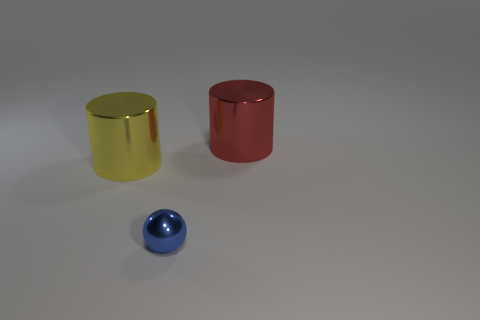Can you describe the surface the objects are on? The surface on which the objects are placed is smooth and has a matte finish, providing a neutral grey background that helps focus attention on the objects themselves. What can you tell me about the texture of this surface? The texture of the surface seems quite fine and even, without any noticeable irregularities or patterns, contributing to the minimalistic aesthetic of the scene. 